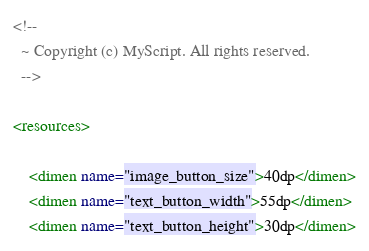<code> <loc_0><loc_0><loc_500><loc_500><_XML_>
<!--
  ~ Copyright (c) MyScript. All rights reserved.
  -->

<resources>

    <dimen name="image_button_size">40dp</dimen>
    <dimen name="text_button_width">55dp</dimen>
    <dimen name="text_button_height">30dp</dimen></code> 